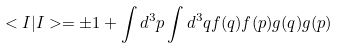<formula> <loc_0><loc_0><loc_500><loc_500>< I | I > = \pm 1 + \int d ^ { 3 } { p } \int d ^ { 3 } { q } f ( { q } ) f ( { p } ) g ( { q } ) g ( { p } )</formula> 